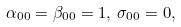<formula> <loc_0><loc_0><loc_500><loc_500>\alpha _ { 0 0 } = \beta _ { 0 0 } = 1 , \, \sigma _ { 0 0 } = 0 ,</formula> 